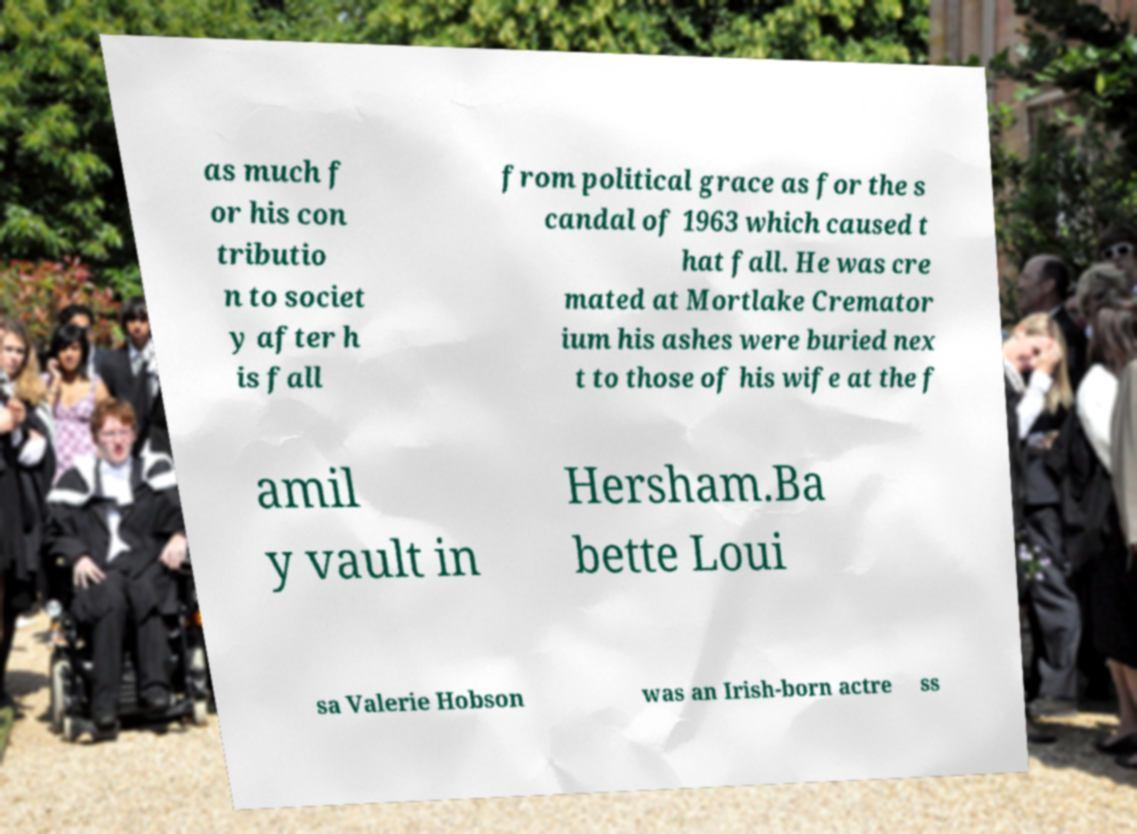For documentation purposes, I need the text within this image transcribed. Could you provide that? as much f or his con tributio n to societ y after h is fall from political grace as for the s candal of 1963 which caused t hat fall. He was cre mated at Mortlake Cremator ium his ashes were buried nex t to those of his wife at the f amil y vault in Hersham.Ba bette Loui sa Valerie Hobson was an Irish-born actre ss 